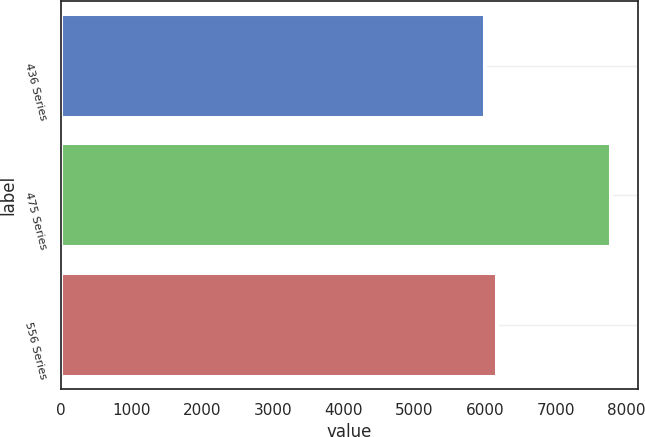<chart> <loc_0><loc_0><loc_500><loc_500><bar_chart><fcel>436 Series<fcel>475 Series<fcel>556 Series<nl><fcel>6000<fcel>7780<fcel>6178<nl></chart> 